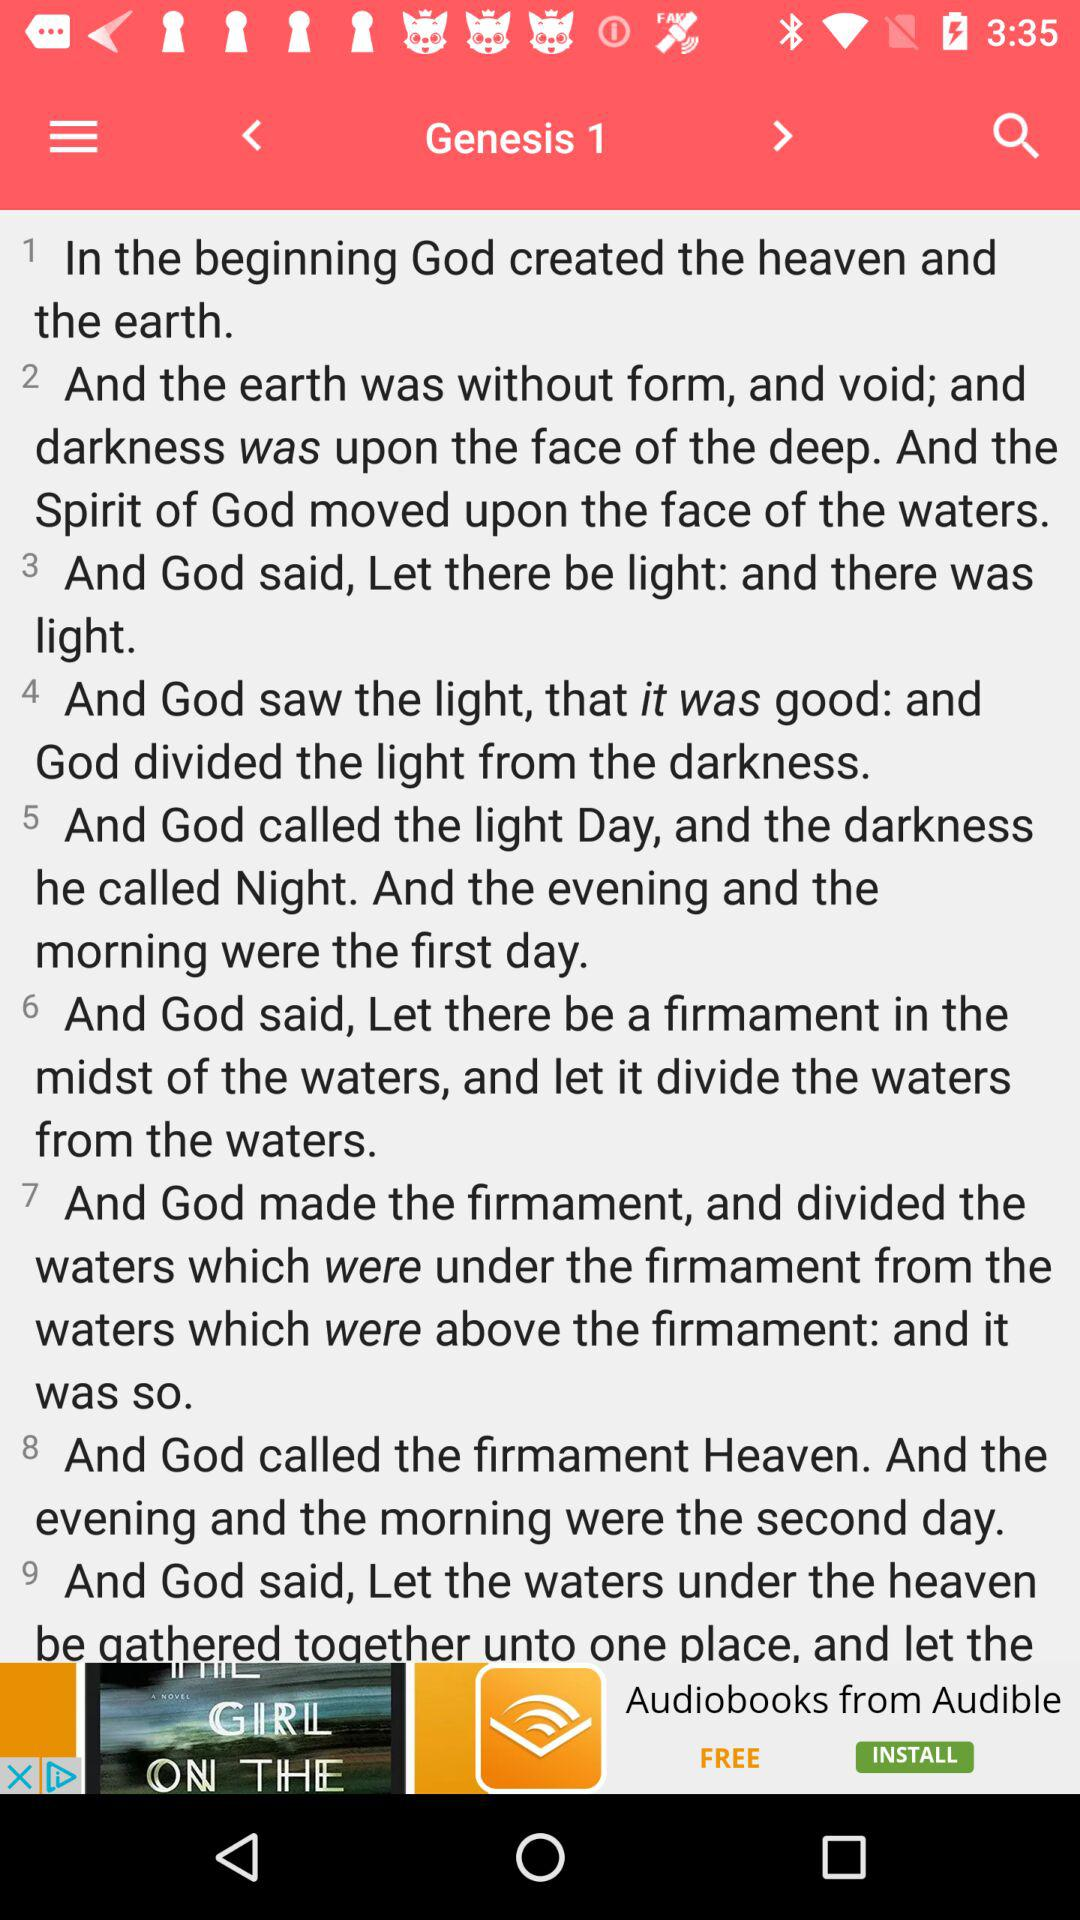What did God call the darkness? God calls the darkness "Night". 